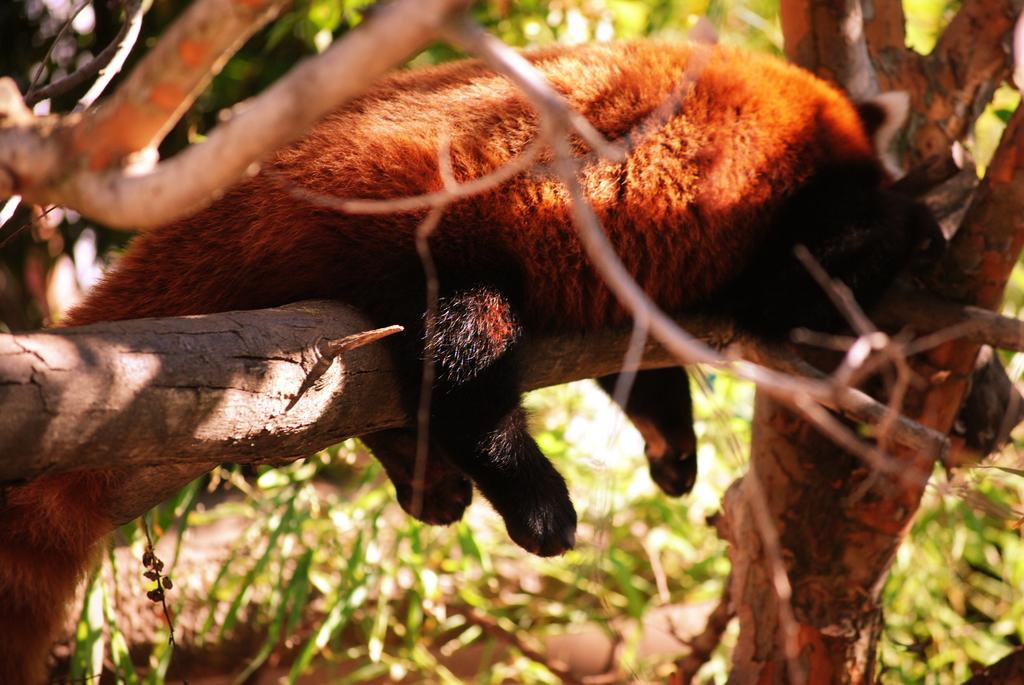What type of animal can be seen in the image? There is an animal in the image. Where is the animal located? The animal is on a tree. Can you describe the position of the tree in the image? The tree is in the middle of the image. What type of pest is the animal attempting to control in the image? There is no indication in the image that the animal is attempting to control any pests. 